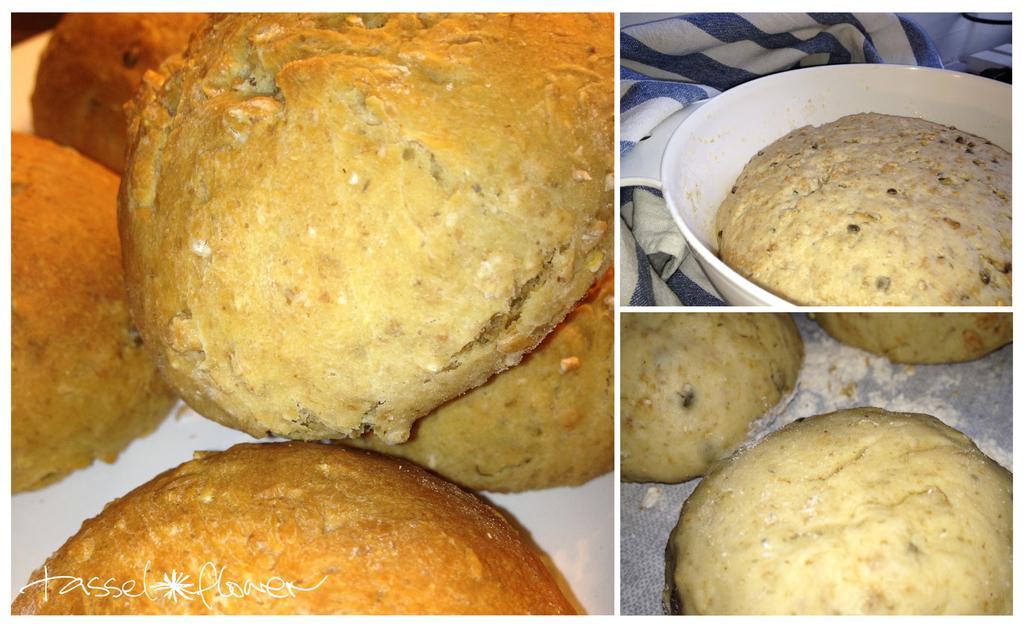Can you describe this image briefly? The picture is a collage of three images. In the picture we can see pancakes. On the right at the top there is a cloth also. 